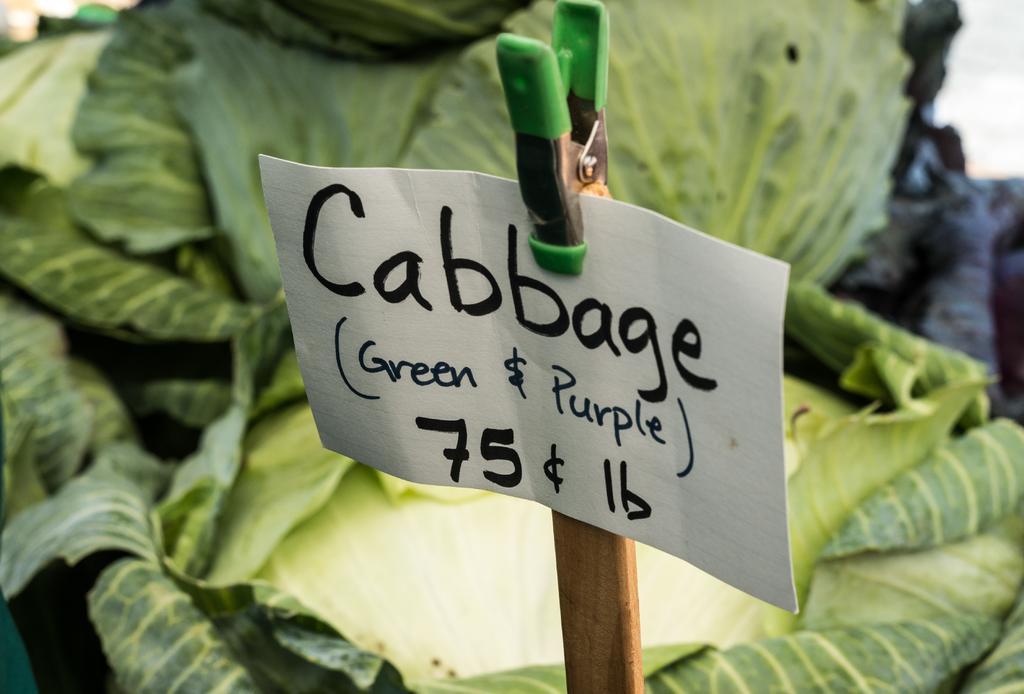Please provide a concise description of this image. In this image I can see the board to the pole. On the board I can see the name cabbage is written. In the back I can see the vegetables which are in green color. 